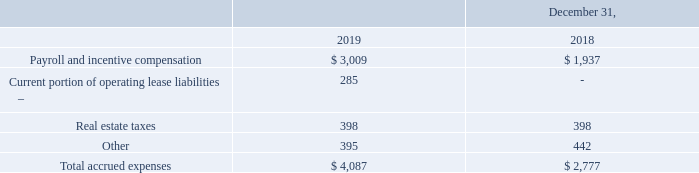Note 6 – Accrued Expenses
Accrued expenses consisted of the following:
What is the value of real estate taxes in 2018? 398. What is the value of  Payroll and incentive compensation  in 2019? 3,009. What is the total accrued expenses in 2019? 4,087. What is the average real estate taxes for 2018 and 2019? (398+398)/2
Answer: 398. What is the change in payroll and incentive compensation between 2018 and 2019? 3,009-1,937
Answer: 1072. What is the percentage change in the total accrued expenses from 2018 to 2019?
Answer scale should be: percent. (4,087-2,777)/2,777
Answer: 47.17. 